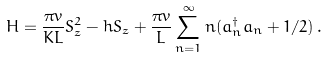<formula> <loc_0><loc_0><loc_500><loc_500>H = \frac { \pi v } { K L } S _ { z } ^ { 2 } - h S _ { z } + \frac { \pi v } { L } \sum _ { n = 1 } ^ { \infty } n ( a _ { n } ^ { \dagger } a _ { n } + 1 / 2 ) \, .</formula> 